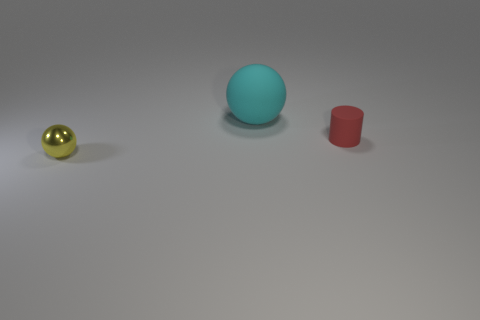Subtract 1 cylinders. How many cylinders are left? 0 Add 3 small balls. How many objects exist? 6 Subtract all red matte cylinders. Subtract all matte things. How many objects are left? 0 Add 2 red matte things. How many red matte things are left? 3 Add 3 big cyan cylinders. How many big cyan cylinders exist? 3 Subtract 0 brown cylinders. How many objects are left? 3 Subtract all spheres. How many objects are left? 1 Subtract all cyan cylinders. Subtract all gray balls. How many cylinders are left? 1 